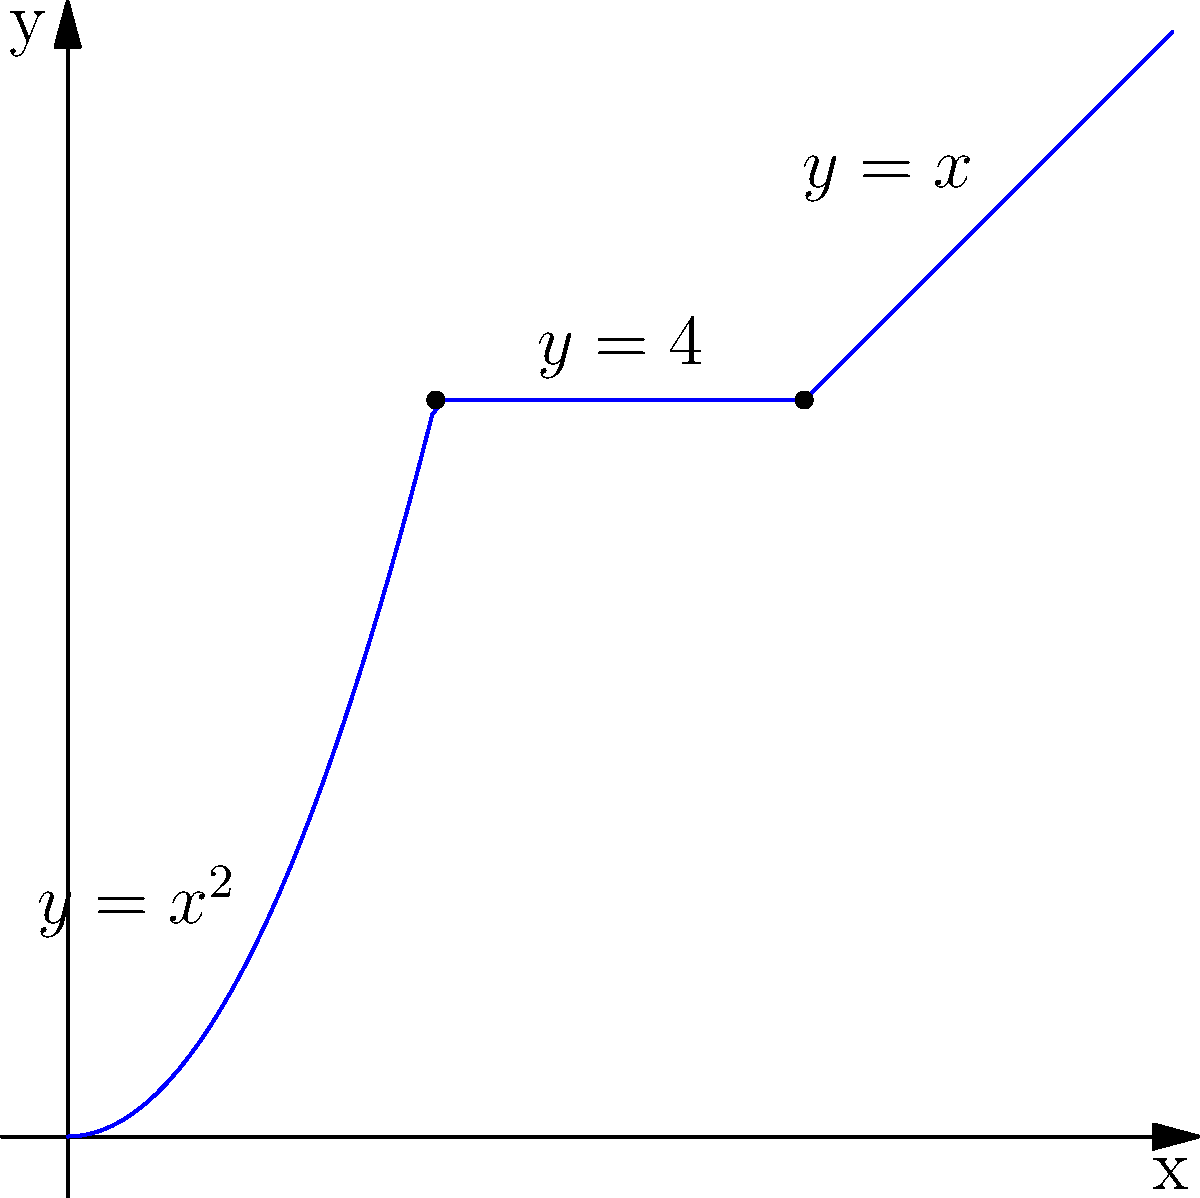As an Assassin scaling a building facade in Renaissance Italy, you encounter a structure with varying surfaces represented by the piecewise function shown in the graph. To optimize your climbing efficiency, you need to find the point where the rate of change in height with respect to horizontal distance is greatest. At which x-coordinate should you begin your ascent to maximize your climbing efficiency? To solve this optimization problem, we need to analyze the rate of change (slope) for each piece of the function:

1. For $0 \leq x < 2$: $y = x^2$
   The derivative is $\frac{dy}{dx} = 2x$, which increases from 0 to 2 as x goes from 0 to 2.

2. For $2 \leq x < 4$: $y = 4$
   The derivative is $\frac{dy}{dx} = 0$, as this is a horizontal line.

3. For $x \geq 4$: $y = x$
   The derivative is $\frac{dy}{dx} = 1$, a constant slope.

The maximum rate of change occurs where the derivative is largest. Comparing the three pieces:

- The first piece has a maximum derivative of 2 at x = 2.
- The second piece has a derivative of 0.
- The third piece has a constant derivative of 1.

Therefore, the maximum rate of change occurs at x = 2, where the derivative of the first piece reaches its maximum value of 2.
Answer: x = 2 